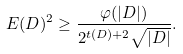<formula> <loc_0><loc_0><loc_500><loc_500>E ( D ) ^ { 2 } \geq \frac { \varphi ( | D | ) } { 2 ^ { t ( D ) + 2 } \sqrt { | D | } } .</formula> 